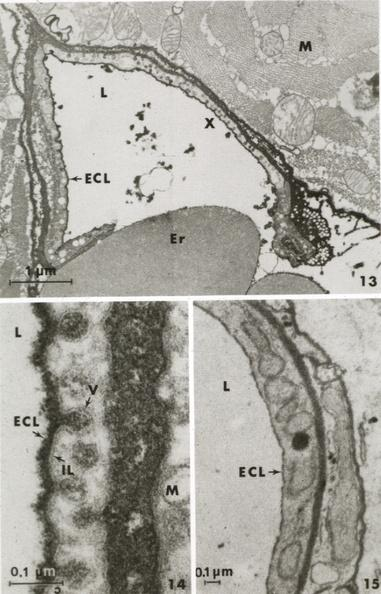s cardiovascular present?
Answer the question using a single word or phrase. Yes 